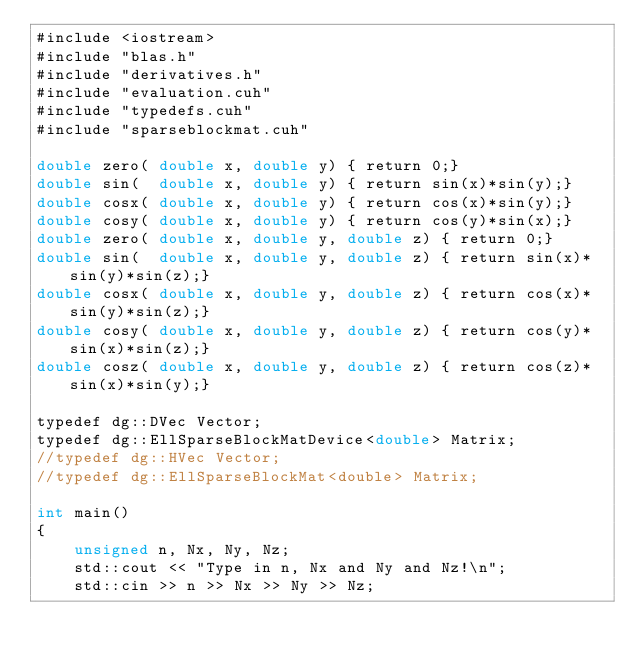Convert code to text. <code><loc_0><loc_0><loc_500><loc_500><_Cuda_>#include <iostream>
#include "blas.h"
#include "derivatives.h"
#include "evaluation.cuh"
#include "typedefs.cuh"
#include "sparseblockmat.cuh"

double zero( double x, double y) { return 0;}
double sin(  double x, double y) { return sin(x)*sin(y);}
double cosx( double x, double y) { return cos(x)*sin(y);}
double cosy( double x, double y) { return cos(y)*sin(x);}
double zero( double x, double y, double z) { return 0;}
double sin(  double x, double y, double z) { return sin(x)*sin(y)*sin(z);}
double cosx( double x, double y, double z) { return cos(x)*sin(y)*sin(z);}
double cosy( double x, double y, double z) { return cos(y)*sin(x)*sin(z);}
double cosz( double x, double y, double z) { return cos(z)*sin(x)*sin(y);}

typedef dg::DVec Vector;
typedef dg::EllSparseBlockMatDevice<double> Matrix;
//typedef dg::HVec Vector;
//typedef dg::EllSparseBlockMat<double> Matrix;

int main()
{
    unsigned n, Nx, Ny, Nz;
    std::cout << "Type in n, Nx and Ny and Nz!\n";
    std::cin >> n >> Nx >> Ny >> Nz;</code> 